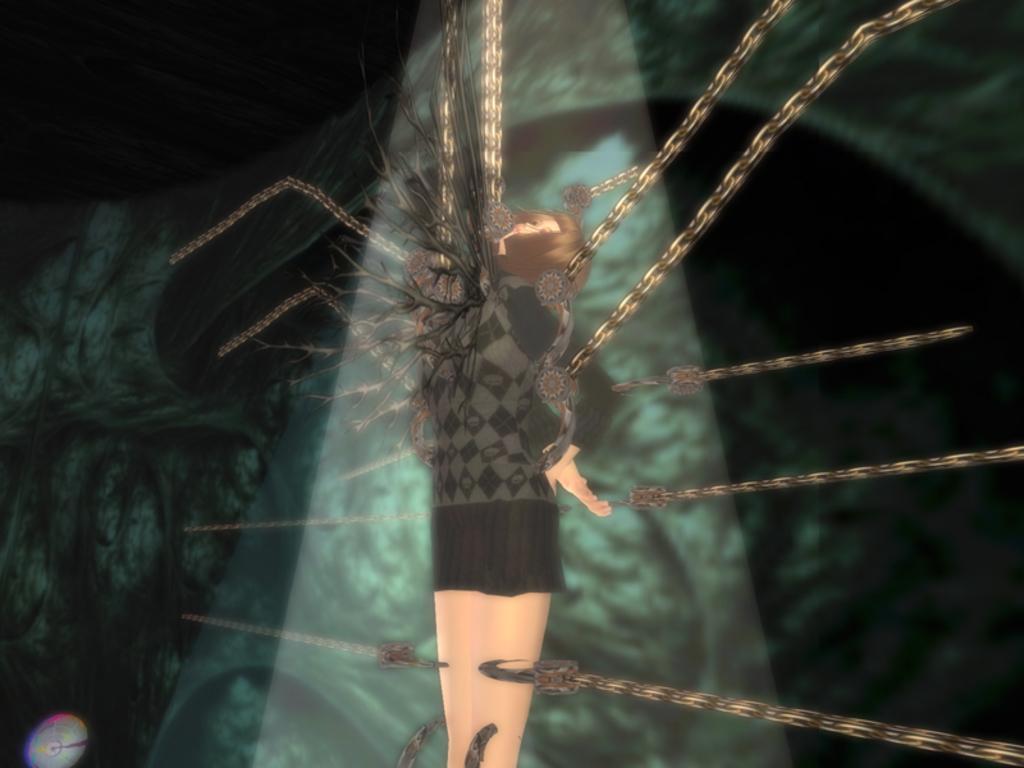Could you give a brief overview of what you see in this image? Here in this picture we can see an animated image of a woman standing and she is tied with chains present over there. 